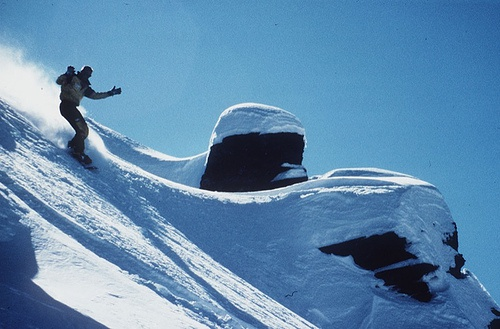Describe the objects in this image and their specific colors. I can see people in gray, black, and blue tones and snowboard in gray, black, navy, darkblue, and lightblue tones in this image. 